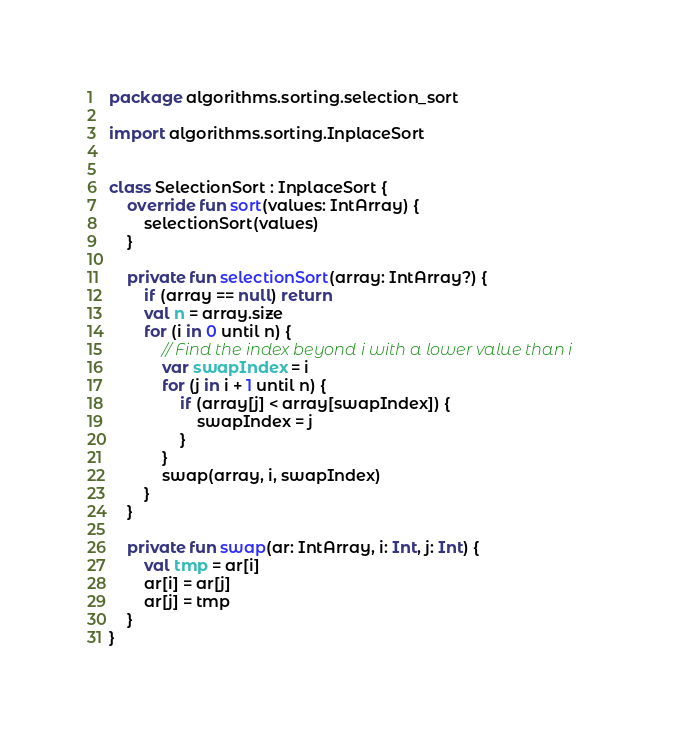Convert code to text. <code><loc_0><loc_0><loc_500><loc_500><_Kotlin_>package algorithms.sorting.selection_sort

import algorithms.sorting.InplaceSort


class SelectionSort : InplaceSort {
    override fun sort(values: IntArray) {
        selectionSort(values)
    }

    private fun selectionSort(array: IntArray?) {
        if (array == null) return
        val n = array.size
        for (i in 0 until n) {
            // Find the index beyond i with a lower value than i
            var swapIndex = i
            for (j in i + 1 until n) {
                if (array[j] < array[swapIndex]) {
                    swapIndex = j
                }
            }
            swap(array, i, swapIndex)
        }
    }

    private fun swap(ar: IntArray, i: Int, j: Int) {
        val tmp = ar[i]
        ar[i] = ar[j]
        ar[j] = tmp
    }
}</code> 